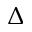<formula> <loc_0><loc_0><loc_500><loc_500>\Delta</formula> 